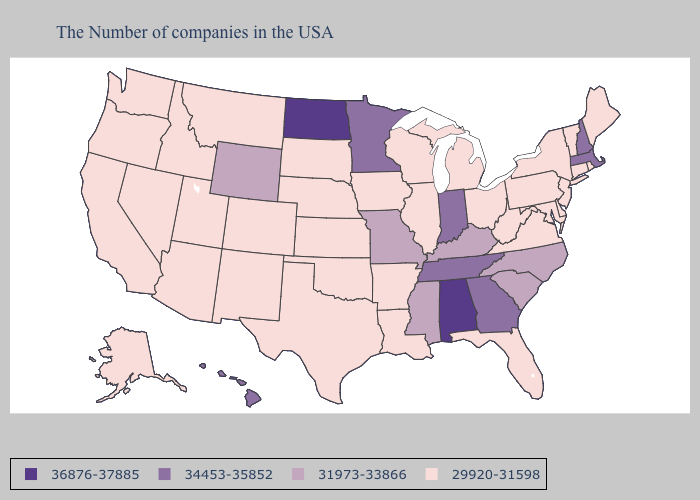Does the map have missing data?
Short answer required. No. Name the states that have a value in the range 36876-37885?
Give a very brief answer. Alabama, North Dakota. Among the states that border North Dakota , which have the lowest value?
Keep it brief. South Dakota, Montana. What is the highest value in the USA?
Keep it brief. 36876-37885. Name the states that have a value in the range 36876-37885?
Be succinct. Alabama, North Dakota. Does Michigan have the lowest value in the USA?
Answer briefly. Yes. Does Alabama have the highest value in the USA?
Give a very brief answer. Yes. Which states have the highest value in the USA?
Quick response, please. Alabama, North Dakota. Is the legend a continuous bar?
Answer briefly. No. Which states hav the highest value in the West?
Concise answer only. Hawaii. What is the highest value in the USA?
Answer briefly. 36876-37885. What is the value of Mississippi?
Give a very brief answer. 31973-33866. Name the states that have a value in the range 36876-37885?
Keep it brief. Alabama, North Dakota. Name the states that have a value in the range 36876-37885?
Concise answer only. Alabama, North Dakota. What is the value of South Dakota?
Be succinct. 29920-31598. 